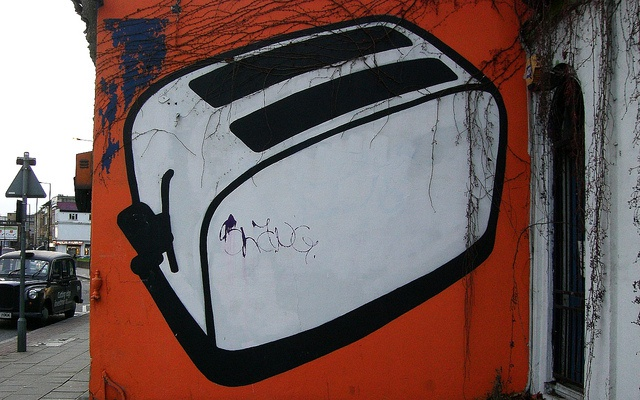Describe the objects in this image and their specific colors. I can see toaster in white, darkgray, black, gray, and maroon tones and car in white, black, gray, darkgray, and lightgray tones in this image. 